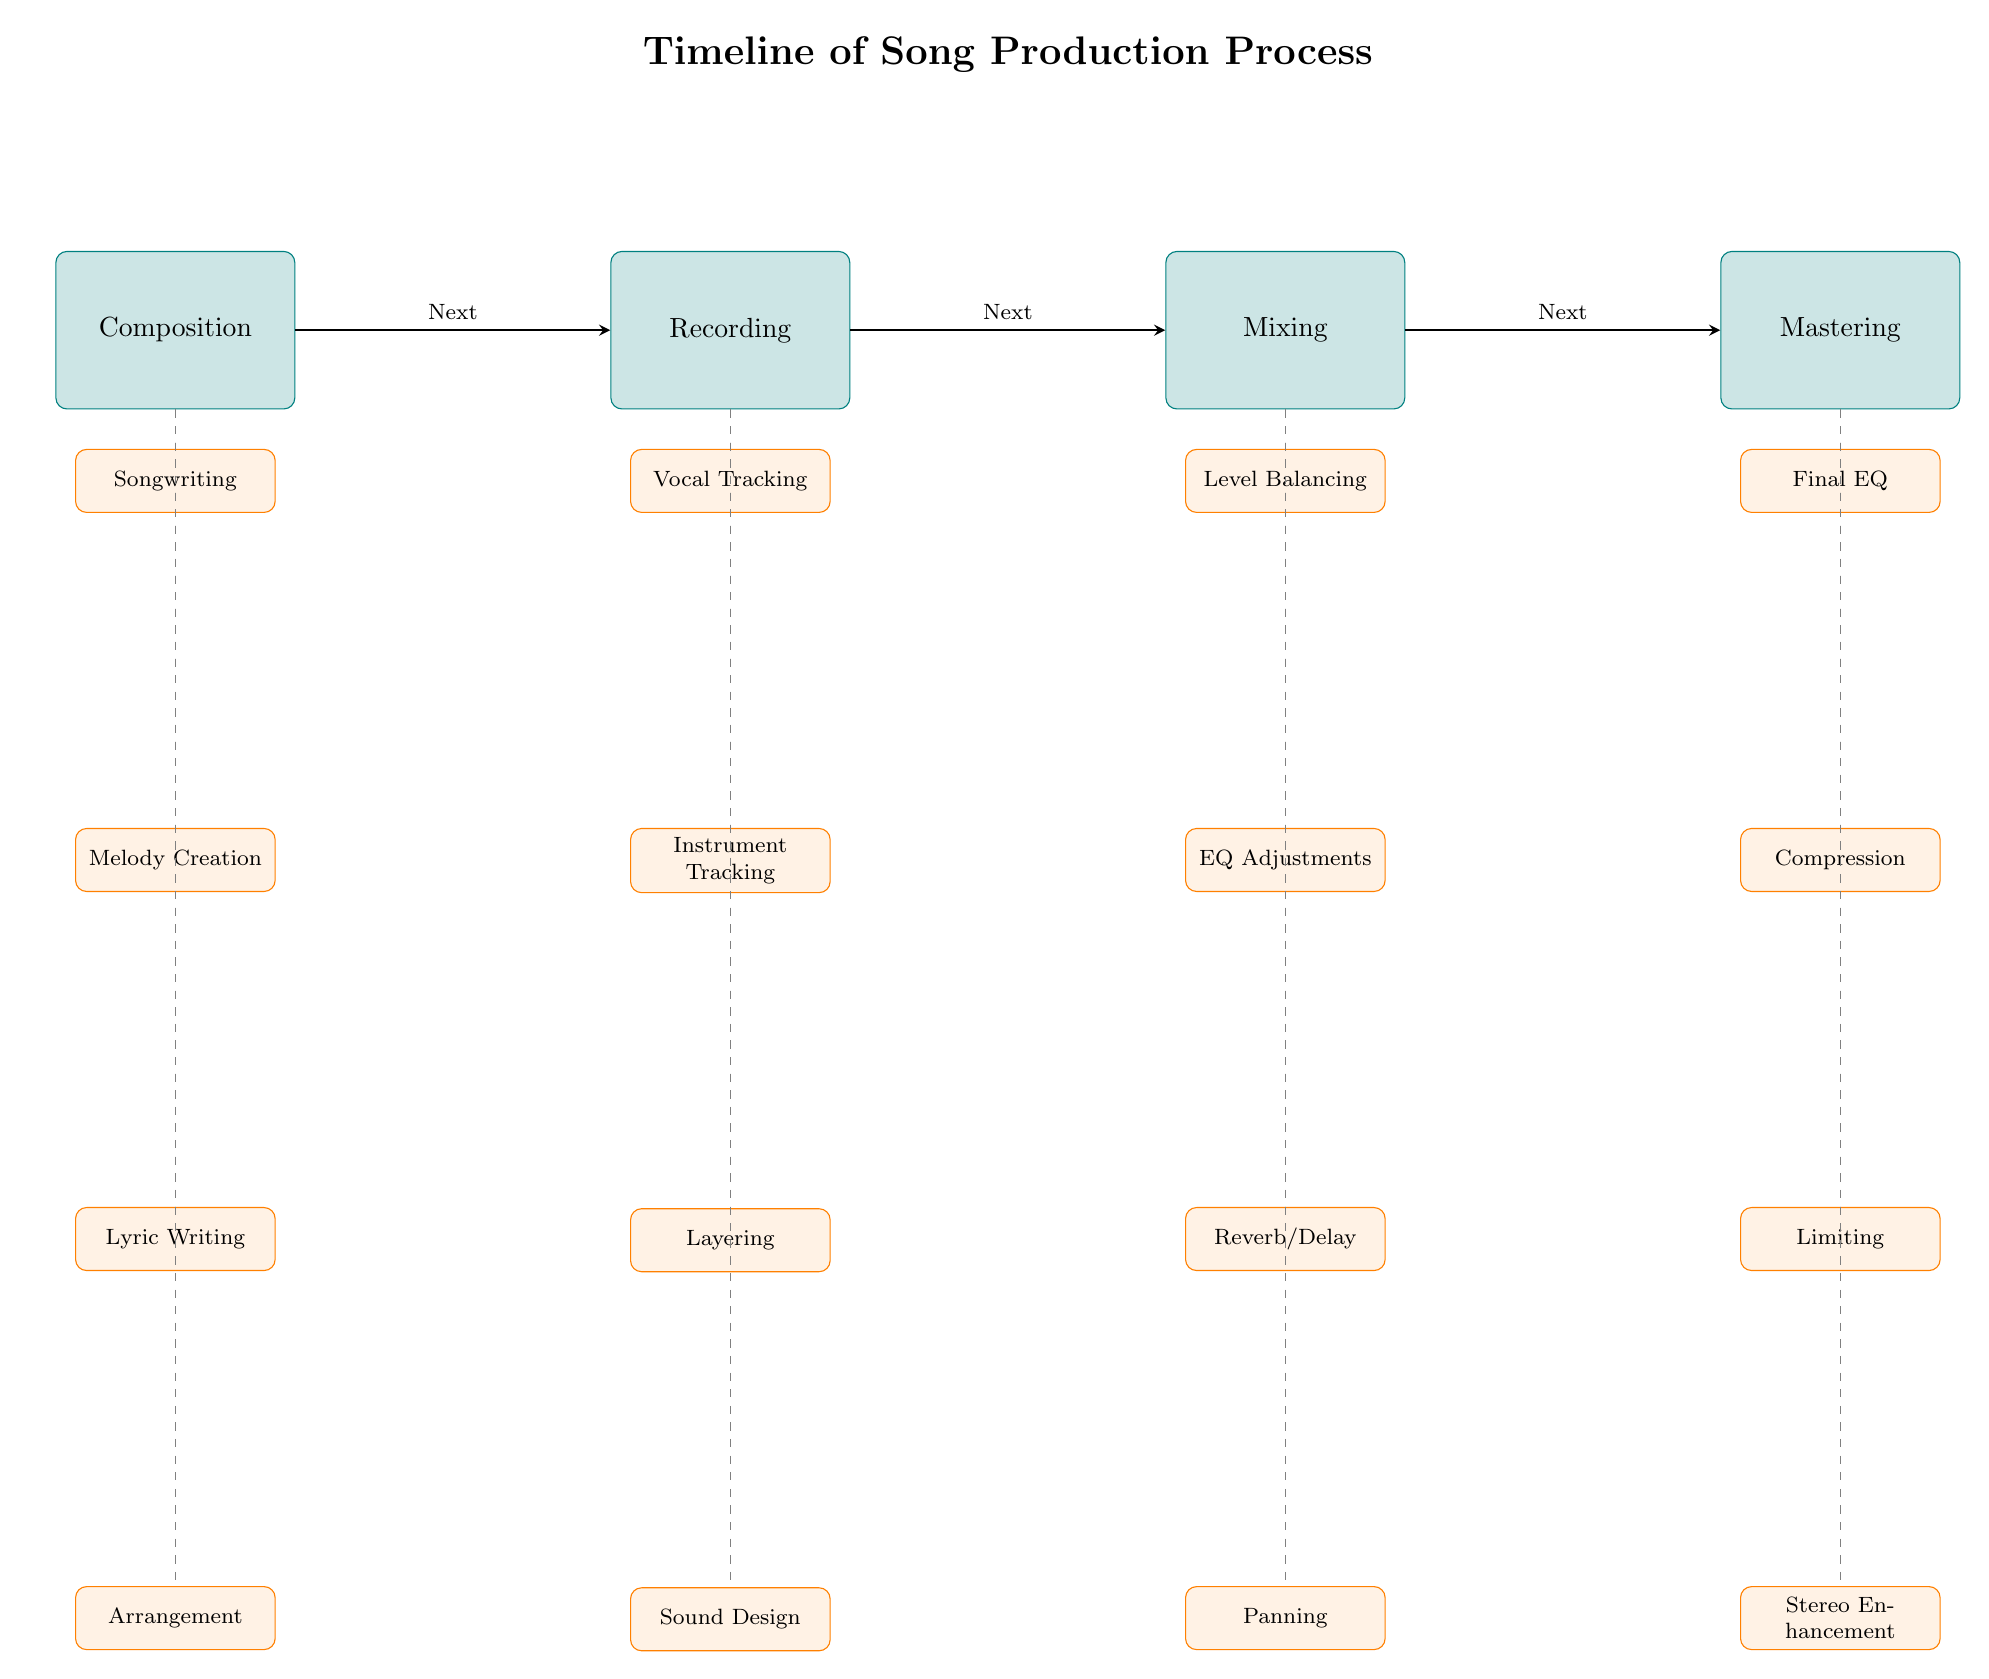What are the four main stages of song production? The diagram clearly lists four main stages connected by arrows. They are: Composition, Recording, Mixing, and Mastering.
Answer: Composition, Recording, Mixing, Mastering How many tasks are listed under the Mixing stage? Under the Mixing stage, there are four tasks listed consecutively: Level Balancing, EQ Adjustments, Reverb/Delay, and Panning.
Answer: 4 What is the first task in the Recording process? The diagram indicates that the first task listed under the Recording process is Vocal Tracking, which is depicted directly below the Recording stage.
Answer: Vocal Tracking Which stage follows Composition in the production timeline? The arrows connecting the nodes indicate the flow of the timeline, showing that Recording follows Composition directly.
Answer: Recording What is the last task in the Mastering stage? The last task listed under the Mastering stage is Stereo Enhancement, located at the bottom of the tasks for that stage in the diagram.
Answer: Stereo Enhancement Describe the relationship between Mixing and Mastering. Mixing leads directly to Mastering as indicated by the arrow connecting the two stages; this means that once Mixing is completed, the process moves to Mastering.
Answer: Next How many tasks are there in total across all stages? By counting the number of tasks listed under each stage, there are 4 (Composition) + 4 (Recording) + 4 (Mixing) + 4 (Mastering) = 16 tasks in total across all stages.
Answer: 16 What do the dashed gray lines represent in this diagram? The dashed gray lines connect the main stages to their respective tasks, indicating that these tasks are part of the larger processes highlighted above them.
Answer: Tasks connection What is the second task listed under the Composition stage? The second task listed under Composition is Melody Creation, positioned below Songwriting, making it the next task in that segment.
Answer: Melody Creation 